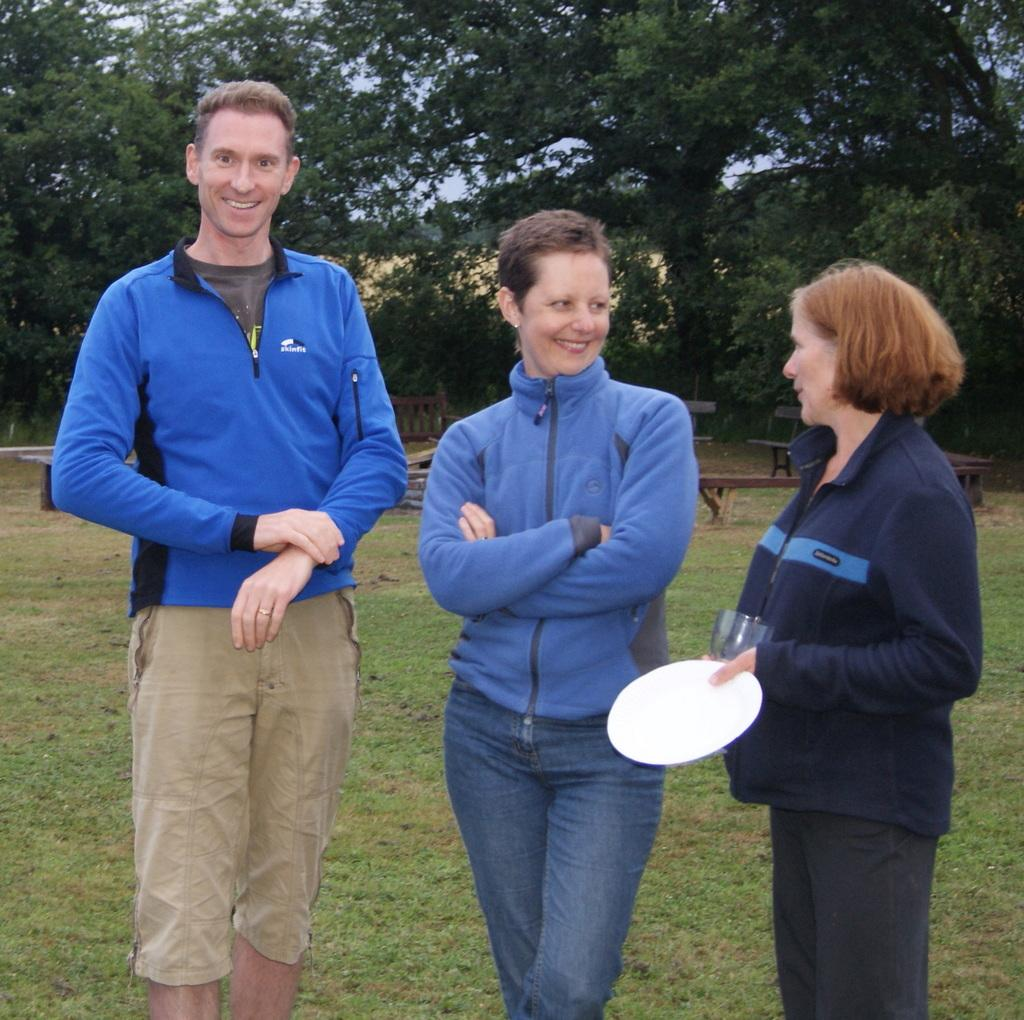How many people are standing in the image? There are three people standing on the ground in the image. What is the woman holding in her hands? The woman is holding a plate and a glass in her hands. What type of vegetation can be seen in the background? Trees are present in the background of the image. What architectural feature is visible in the background? There is a bench in the background. What part of the natural environment is visible in the image? The sky is visible in the background of the image. How does the woman rub her stomach in the image? There is no indication in the image that the woman is rubbing her stomach. 